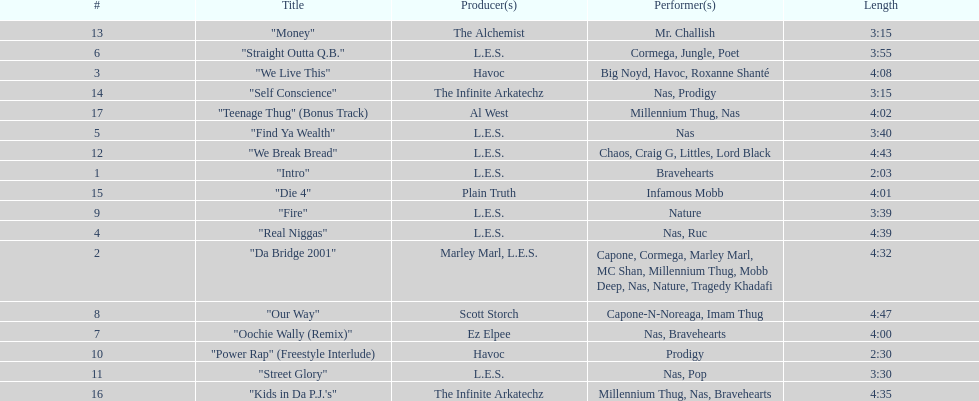How many songs were on the track list? 17. 